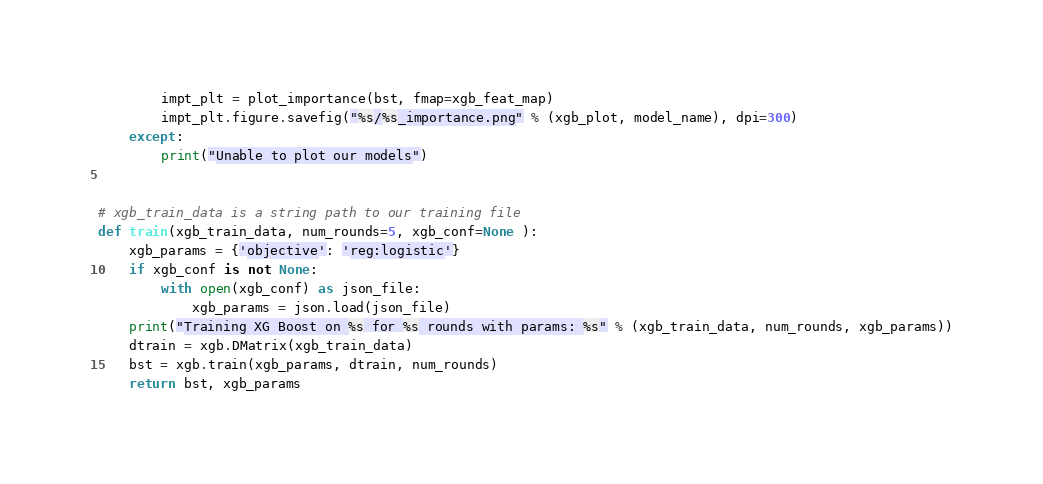Convert code to text. <code><loc_0><loc_0><loc_500><loc_500><_Python_>        impt_plt = plot_importance(bst, fmap=xgb_feat_map)
        impt_plt.figure.savefig("%s/%s_importance.png" % (xgb_plot, model_name), dpi=300)
    except:
        print("Unable to plot our models")


# xgb_train_data is a string path to our training file
def train(xgb_train_data, num_rounds=5, xgb_conf=None ):
    xgb_params = {'objective': 'reg:logistic'}
    if xgb_conf is not None:
        with open(xgb_conf) as json_file:
            xgb_params = json.load(json_file)
    print("Training XG Boost on %s for %s rounds with params: %s" % (xgb_train_data, num_rounds, xgb_params))
    dtrain = xgb.DMatrix(xgb_train_data)
    bst = xgb.train(xgb_params, dtrain, num_rounds)
    return bst, xgb_params
</code> 